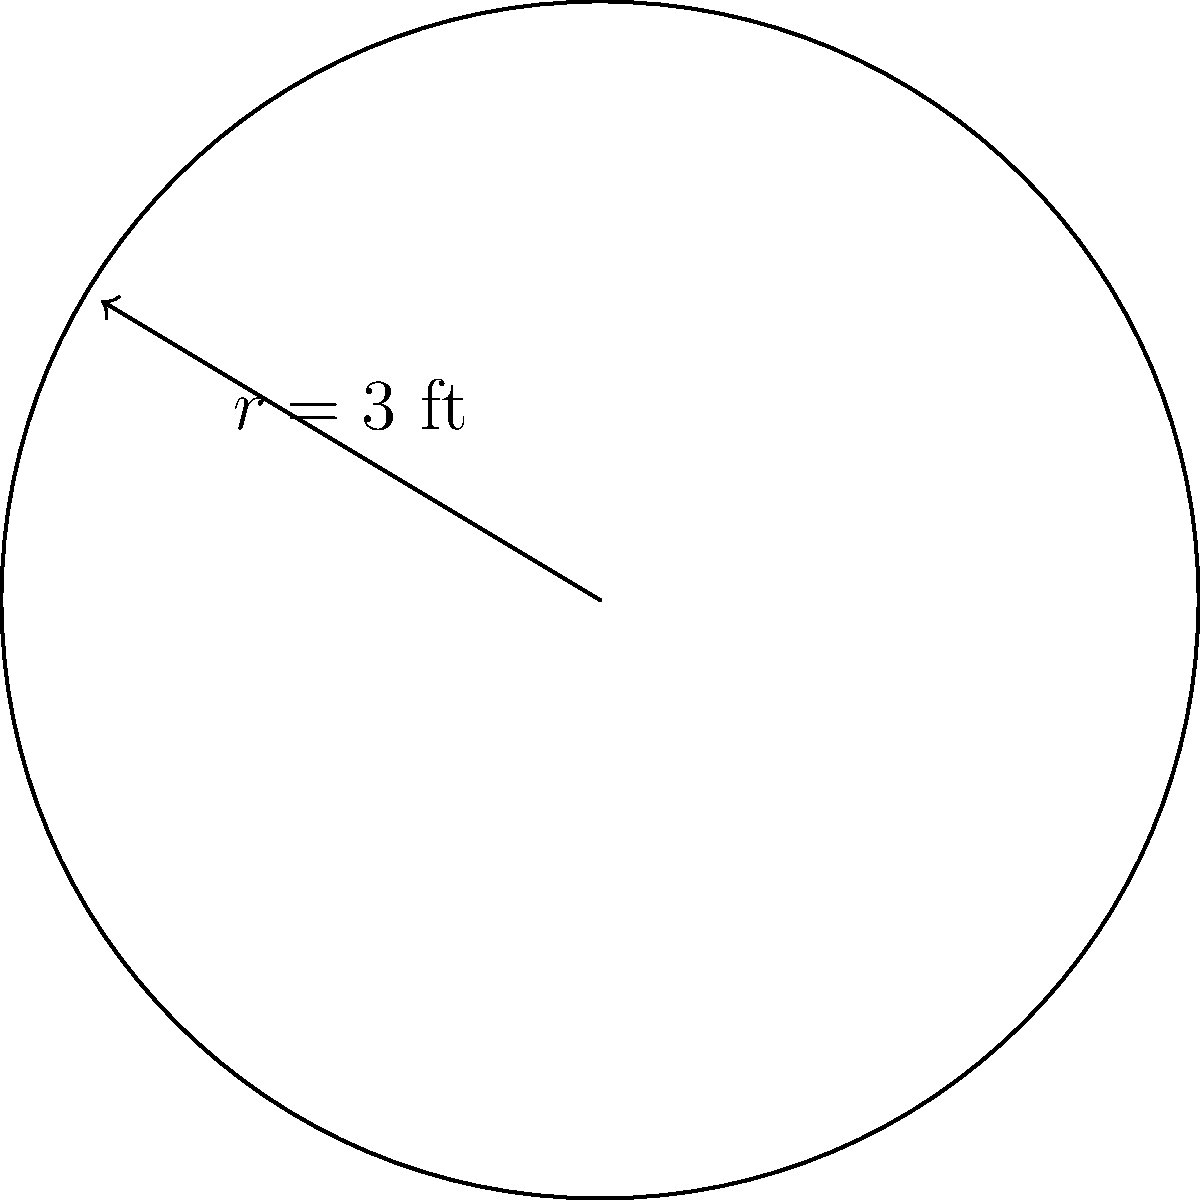During a recent flooding incident, your circular rug was damaged. If the rug has a radius of 3 feet, what is the total area of the rug that needs to be replaced? Round your answer to the nearest square foot. To find the area of the circular rug, we'll use the formula for the area of a circle:

$$A = \pi r^2$$

Where:
$A$ is the area
$\pi$ is approximately 3.14159
$r$ is the radius of the circle

Given:
$r = 3$ feet

Let's calculate:

1) Substitute the values into the formula:
   $$A = \pi \times 3^2$$

2) Calculate the square of the radius:
   $$A = \pi \times 9$$

3) Multiply by $\pi$:
   $$A = 28.27431...$$

4) Round to the nearest square foot:
   $$A \approx 28 \text{ sq ft}$$

Therefore, the area of the rug that needs to be replaced is approximately 28 square feet.
Answer: 28 sq ft 